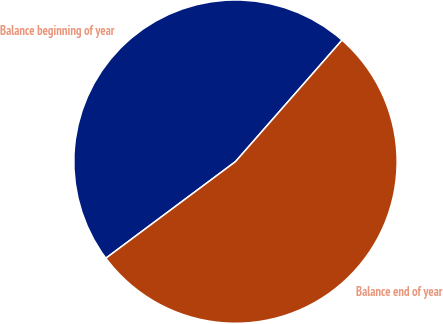<chart> <loc_0><loc_0><loc_500><loc_500><pie_chart><fcel>Balance beginning of year<fcel>Balance end of year<nl><fcel>46.65%<fcel>53.35%<nl></chart> 